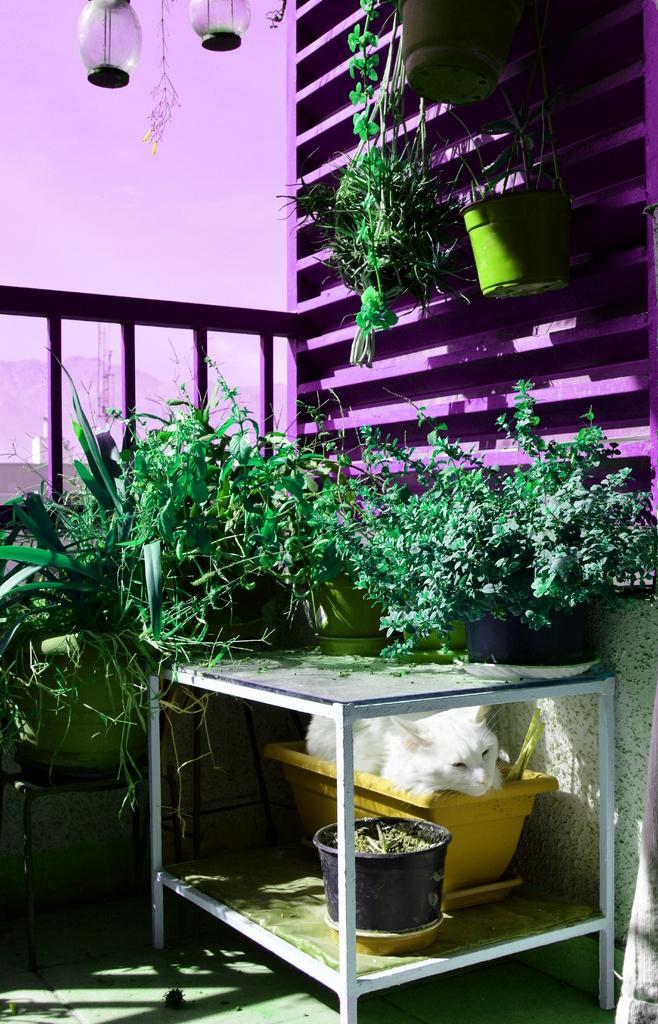In one or two sentences, can you explain what this image depicts? In this image there is a table having pots with the plates on it. There is a cat under the table inside a pot. There are few pots with plants beside the table. There is a fence behind it. There are two pots hanged to the wall. At the left side there are two lamps at the top of the image. 